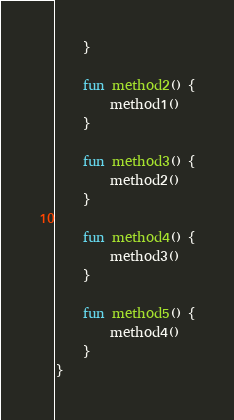<code> <loc_0><loc_0><loc_500><loc_500><_Kotlin_>    }

    fun method2() {
        method1()
    }

    fun method3() {
        method2()
    }

    fun method4() {
        method3()
    }

    fun method5() {
        method4()
    }
}
</code> 